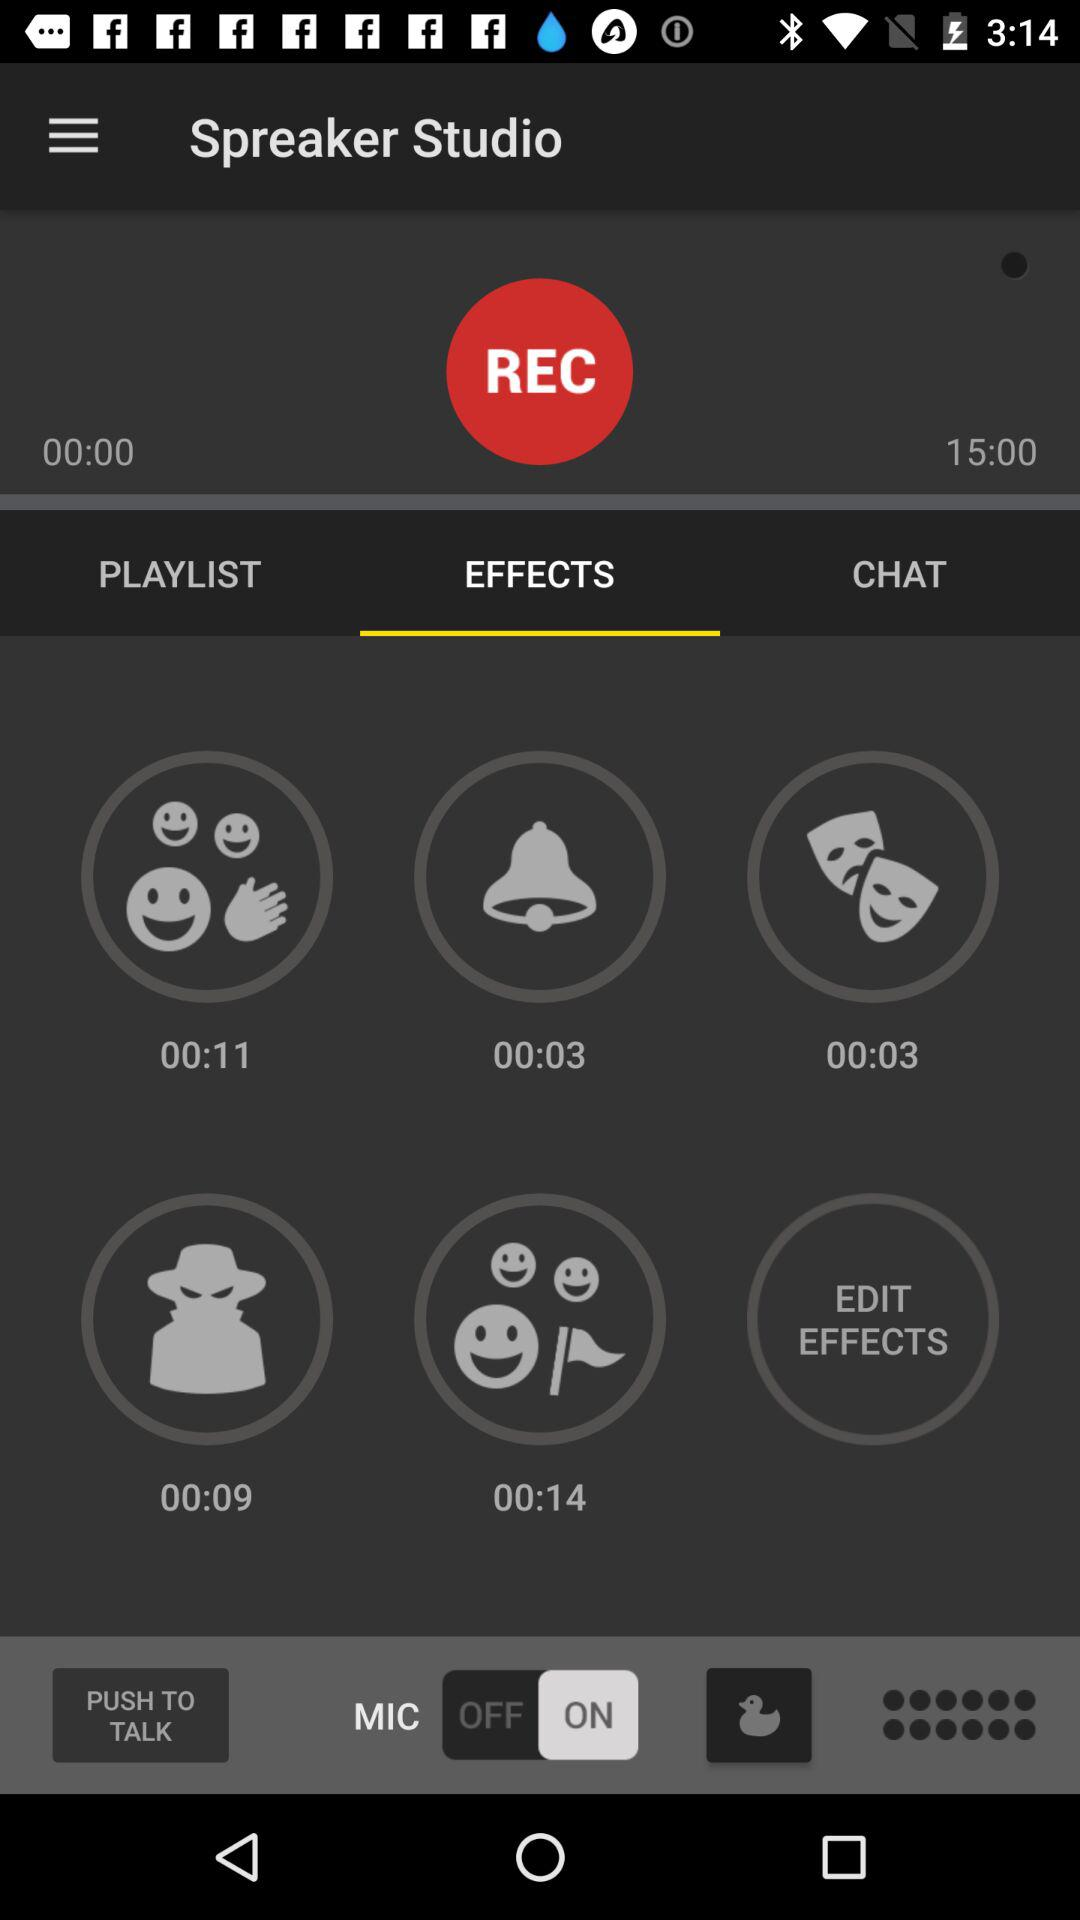What is the recording duration? The recording duration is 15 minutes. 